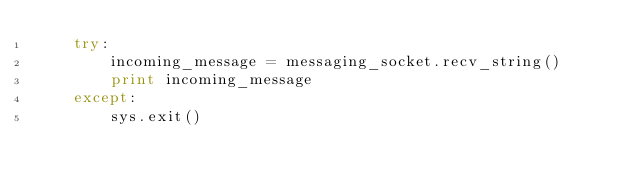<code> <loc_0><loc_0><loc_500><loc_500><_Python_>    try:
        incoming_message = messaging_socket.recv_string()
        print incoming_message
    except:
        sys.exit()

</code> 